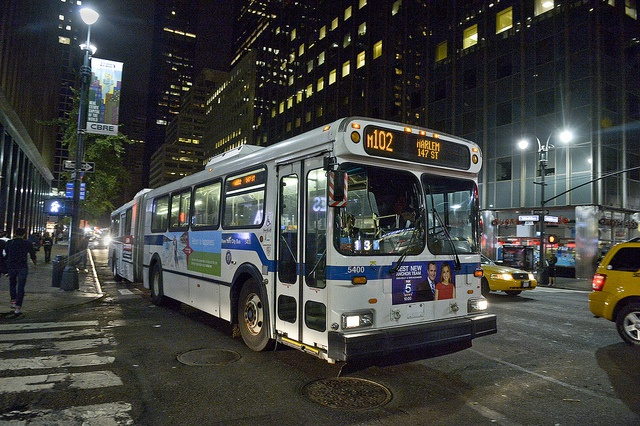Describe the objects in this image and their specific colors. I can see bus in black, darkgray, gray, and navy tones, car in black, olive, and gray tones, car in black, olive, and gray tones, people in black, gray, and darkgreen tones, and people in black, gray, lightgray, and darkgray tones in this image. 